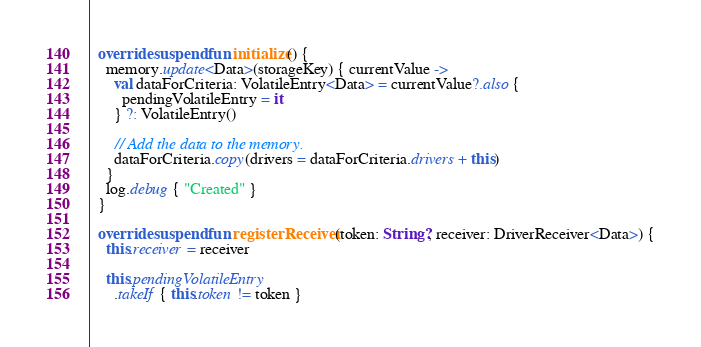Convert code to text. <code><loc_0><loc_0><loc_500><loc_500><_Kotlin_>
  override suspend fun initialize() {
    memory.update<Data>(storageKey) { currentValue ->
      val dataForCriteria: VolatileEntry<Data> = currentValue?.also {
        pendingVolatileEntry = it
      } ?: VolatileEntry()

      // Add the data to the memory.
      dataForCriteria.copy(drivers = dataForCriteria.drivers + this)
    }
    log.debug { "Created" }
  }

  override suspend fun registerReceiver(token: String?, receiver: DriverReceiver<Data>) {
    this.receiver = receiver

    this.pendingVolatileEntry
      .takeIf { this.token != token }</code> 